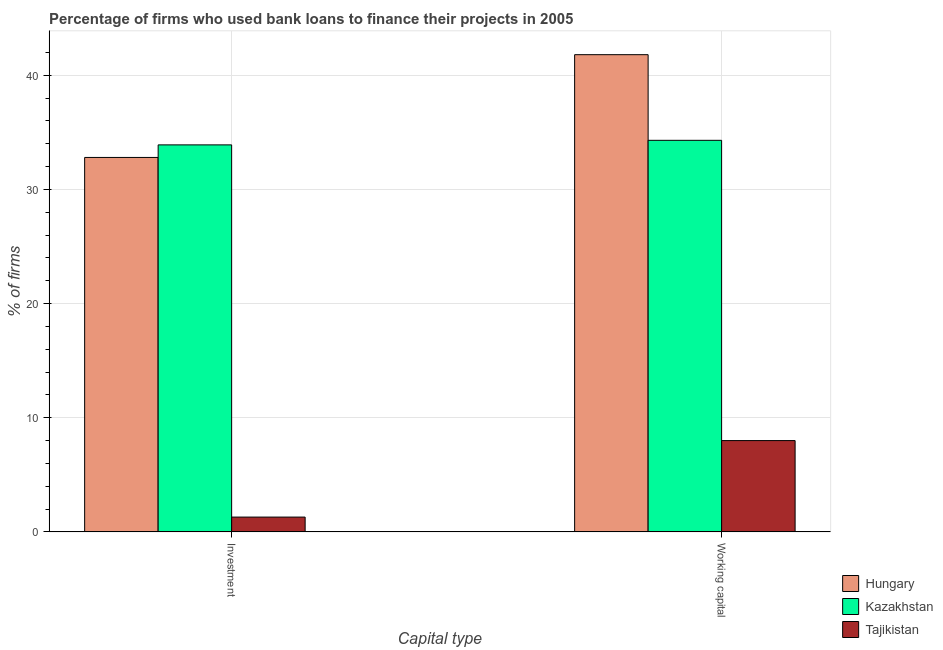Are the number of bars per tick equal to the number of legend labels?
Keep it short and to the point. Yes. Are the number of bars on each tick of the X-axis equal?
Give a very brief answer. Yes. How many bars are there on the 2nd tick from the left?
Give a very brief answer. 3. What is the label of the 2nd group of bars from the left?
Ensure brevity in your answer.  Working capital. What is the percentage of firms using banks to finance investment in Kazakhstan?
Give a very brief answer. 33.9. Across all countries, what is the maximum percentage of firms using banks to finance investment?
Your answer should be very brief. 33.9. Across all countries, what is the minimum percentage of firms using banks to finance investment?
Provide a short and direct response. 1.3. In which country was the percentage of firms using banks to finance investment maximum?
Give a very brief answer. Kazakhstan. In which country was the percentage of firms using banks to finance investment minimum?
Provide a succinct answer. Tajikistan. What is the total percentage of firms using banks to finance investment in the graph?
Provide a short and direct response. 68. What is the difference between the percentage of firms using banks to finance investment in Hungary and that in Kazakhstan?
Offer a terse response. -1.1. What is the difference between the percentage of firms using banks to finance investment in Kazakhstan and the percentage of firms using banks to finance working capital in Hungary?
Provide a short and direct response. -7.9. What is the average percentage of firms using banks to finance working capital per country?
Provide a short and direct response. 28.03. What is the difference between the percentage of firms using banks to finance investment and percentage of firms using banks to finance working capital in Kazakhstan?
Provide a succinct answer. -0.4. In how many countries, is the percentage of firms using banks to finance working capital greater than 12 %?
Offer a very short reply. 2. What is the ratio of the percentage of firms using banks to finance working capital in Kazakhstan to that in Tajikistan?
Offer a very short reply. 4.29. What does the 2nd bar from the left in Working capital represents?
Give a very brief answer. Kazakhstan. What does the 2nd bar from the right in Investment represents?
Your answer should be compact. Kazakhstan. How many bars are there?
Ensure brevity in your answer.  6. Does the graph contain any zero values?
Give a very brief answer. No. Where does the legend appear in the graph?
Your answer should be very brief. Bottom right. What is the title of the graph?
Ensure brevity in your answer.  Percentage of firms who used bank loans to finance their projects in 2005. Does "Singapore" appear as one of the legend labels in the graph?
Your answer should be compact. No. What is the label or title of the X-axis?
Your response must be concise. Capital type. What is the label or title of the Y-axis?
Your answer should be compact. % of firms. What is the % of firms of Hungary in Investment?
Offer a terse response. 32.8. What is the % of firms in Kazakhstan in Investment?
Ensure brevity in your answer.  33.9. What is the % of firms of Hungary in Working capital?
Offer a very short reply. 41.8. What is the % of firms in Kazakhstan in Working capital?
Offer a very short reply. 34.3. Across all Capital type, what is the maximum % of firms in Hungary?
Offer a very short reply. 41.8. Across all Capital type, what is the maximum % of firms in Kazakhstan?
Offer a very short reply. 34.3. Across all Capital type, what is the maximum % of firms in Tajikistan?
Provide a short and direct response. 8. Across all Capital type, what is the minimum % of firms of Hungary?
Provide a short and direct response. 32.8. Across all Capital type, what is the minimum % of firms of Kazakhstan?
Keep it short and to the point. 33.9. Across all Capital type, what is the minimum % of firms in Tajikistan?
Your answer should be very brief. 1.3. What is the total % of firms in Hungary in the graph?
Give a very brief answer. 74.6. What is the total % of firms of Kazakhstan in the graph?
Provide a short and direct response. 68.2. What is the difference between the % of firms of Tajikistan in Investment and that in Working capital?
Your response must be concise. -6.7. What is the difference between the % of firms of Hungary in Investment and the % of firms of Kazakhstan in Working capital?
Ensure brevity in your answer.  -1.5. What is the difference between the % of firms of Hungary in Investment and the % of firms of Tajikistan in Working capital?
Your response must be concise. 24.8. What is the difference between the % of firms in Kazakhstan in Investment and the % of firms in Tajikistan in Working capital?
Your response must be concise. 25.9. What is the average % of firms of Hungary per Capital type?
Make the answer very short. 37.3. What is the average % of firms in Kazakhstan per Capital type?
Provide a short and direct response. 34.1. What is the average % of firms of Tajikistan per Capital type?
Your response must be concise. 4.65. What is the difference between the % of firms in Hungary and % of firms in Tajikistan in Investment?
Make the answer very short. 31.5. What is the difference between the % of firms in Kazakhstan and % of firms in Tajikistan in Investment?
Offer a very short reply. 32.6. What is the difference between the % of firms in Hungary and % of firms in Kazakhstan in Working capital?
Keep it short and to the point. 7.5. What is the difference between the % of firms of Hungary and % of firms of Tajikistan in Working capital?
Offer a terse response. 33.8. What is the difference between the % of firms of Kazakhstan and % of firms of Tajikistan in Working capital?
Give a very brief answer. 26.3. What is the ratio of the % of firms of Hungary in Investment to that in Working capital?
Your answer should be compact. 0.78. What is the ratio of the % of firms of Kazakhstan in Investment to that in Working capital?
Keep it short and to the point. 0.99. What is the ratio of the % of firms in Tajikistan in Investment to that in Working capital?
Give a very brief answer. 0.16. What is the difference between the highest and the second highest % of firms of Hungary?
Provide a short and direct response. 9. What is the difference between the highest and the second highest % of firms in Kazakhstan?
Ensure brevity in your answer.  0.4. What is the difference between the highest and the second highest % of firms in Tajikistan?
Offer a terse response. 6.7. What is the difference between the highest and the lowest % of firms of Hungary?
Provide a succinct answer. 9. What is the difference between the highest and the lowest % of firms in Kazakhstan?
Offer a terse response. 0.4. 